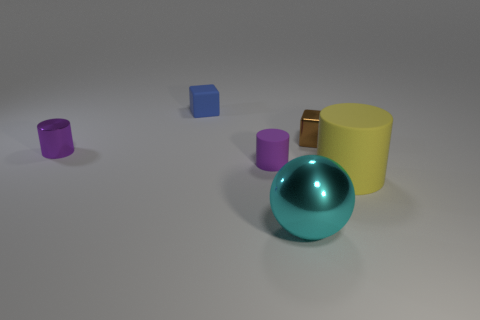What number of small things are behind the small brown object?
Keep it short and to the point. 1. Does the purple object that is on the right side of the blue object have the same size as the cyan shiny object right of the tiny blue rubber cube?
Make the answer very short. No. What number of other things are there of the same size as the purple metal cylinder?
Your response must be concise. 3. What is the material of the small thing that is to the right of the large cyan sphere that is right of the small matte cylinder behind the large cylinder?
Give a very brief answer. Metal. Is the size of the cyan ball the same as the cube to the right of the large cyan metallic ball?
Keep it short and to the point. No. There is a thing that is right of the tiny blue matte object and behind the small purple metallic object; what is its size?
Give a very brief answer. Small. Are there any other tiny cylinders that have the same color as the tiny rubber cylinder?
Make the answer very short. Yes. There is a small cube that is to the right of the small matte object that is to the right of the matte cube; what color is it?
Make the answer very short. Brown. Is the number of shiny things in front of the cyan metallic thing less than the number of tiny blue things that are in front of the yellow object?
Your answer should be compact. No. Is the size of the purple shiny thing the same as the blue rubber cube?
Your answer should be compact. Yes. 